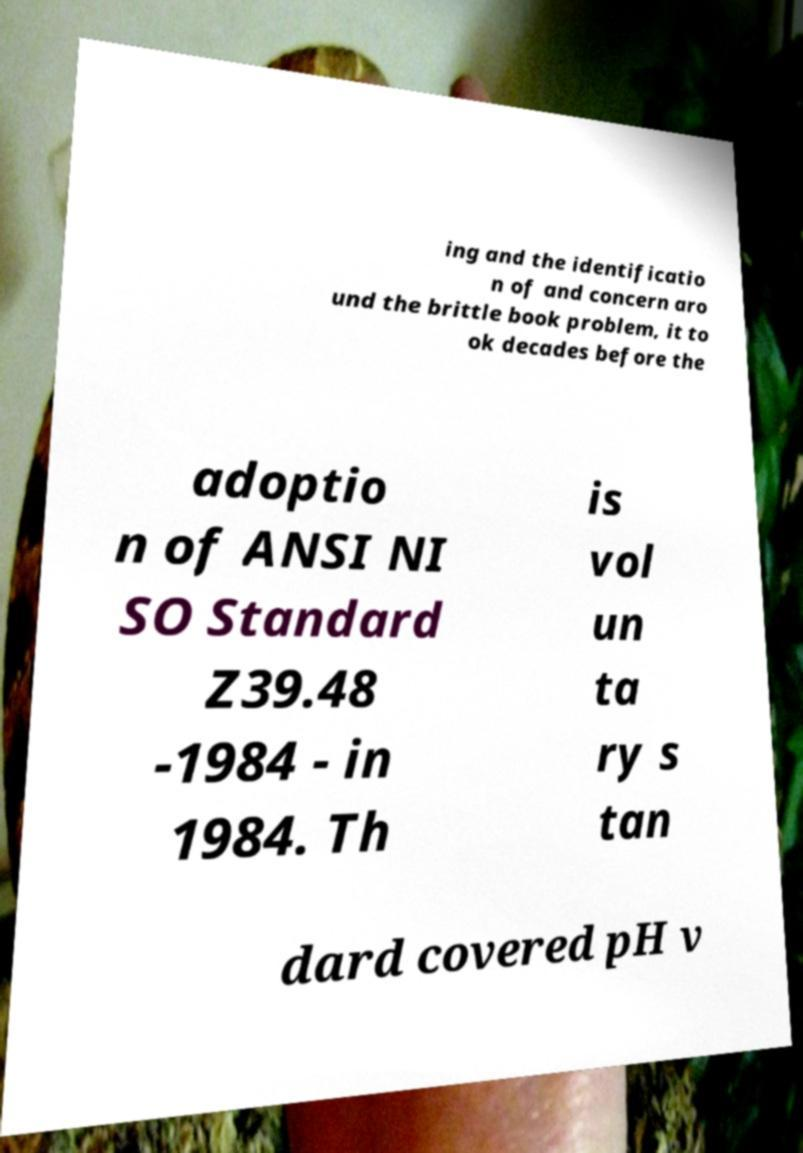I need the written content from this picture converted into text. Can you do that? ing and the identificatio n of and concern aro und the brittle book problem, it to ok decades before the adoptio n of ANSI NI SO Standard Z39.48 -1984 - in 1984. Th is vol un ta ry s tan dard covered pH v 